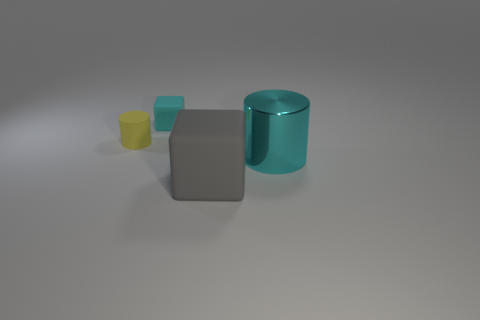What number of cyan metal objects are the same shape as the yellow thing?
Provide a succinct answer. 1. There is a cylinder on the right side of the tiny rubber cylinder behind the large block; what is its material?
Your answer should be compact. Metal. There is a rubber block in front of the big metal cylinder; what size is it?
Give a very brief answer. Large. What number of yellow objects are big metal cylinders or small matte blocks?
Your answer should be very brief. 0. Is there any other thing that has the same material as the big cyan cylinder?
Ensure brevity in your answer.  No. There is a large thing that is the same shape as the tiny cyan matte thing; what is it made of?
Offer a terse response. Rubber. Are there an equal number of cyan objects that are to the left of the small rubber block and large cyan rubber cylinders?
Your answer should be compact. Yes. There is a thing that is on the left side of the metallic object and right of the cyan block; how big is it?
Your response must be concise. Large. Is there any other thing that is the same color as the big shiny thing?
Make the answer very short. Yes. What size is the cyan object that is on the right side of the large thing in front of the cyan cylinder?
Provide a succinct answer. Large. 